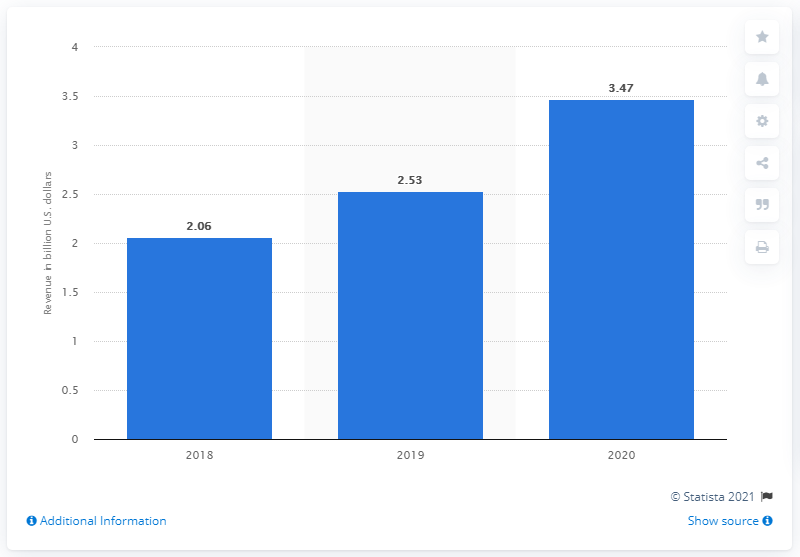Draw attention to some important aspects in this diagram. In the previous year, Caesars Entertainment's revenue was 2.53 million. In 2020, Caesars generated approximately 3.47 billion dollars in revenue. 